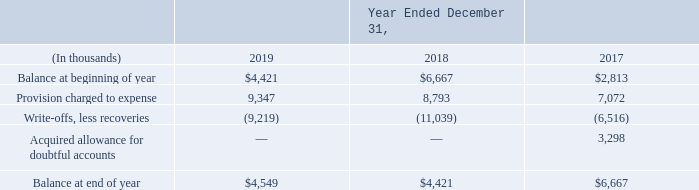Accounts Receivable and Allowance for Doubtful Accounts
Accounts receivable consists primarily of amounts due to the Company from normal business activities. We maintain an allowance for doubtful accounts for estimated losses that result from the inability of our customers to make required payments.
The allowance for doubtful accounts is maintained based on customer payment levels, historical experience and management’s views on trends in the overall receivable agings. In addition, for larger accounts, we perform analyses of risks on a customer-specific basis. We perform ongoing credit evaluations of our customers’ financial condition and management believes that an adequate allowance for doubtful accounts has been provided.
Uncollectible accounts are removed from accounts receivable and are charged against the allowance for doubtful accounts when internal collection efforts have been unsuccessful. The following table summarizes the activity in allowance for doubtful accounts for the years ended December 31, 2019, 2018 and 2017:
What does the accounts receivable consist of? Consists primarily of amounts due to the company from normal business activities. What was the provision charged to expense in 2019?
Answer scale should be: thousand. 9,347. What was the Balance at beginning of year in 2019?
Answer scale should be: thousand. $4,421. What was the increase / (decrease) in the balance at beginning of year from 2018 to 2019?
Answer scale should be: thousand. 4,421 - 6,667
Answer: -2246. What was the average provision charged to expense for 2017-2019?
Answer scale should be: thousand. (9,347 + 8,793 + 7,072) / 3
Answer: 8404. What was the increase / (decrease) in the Acquired allowance for doubtful accounts from 2017 to 2018?
Answer scale should be: thousand. 0 - 3,298
Answer: -3298. 